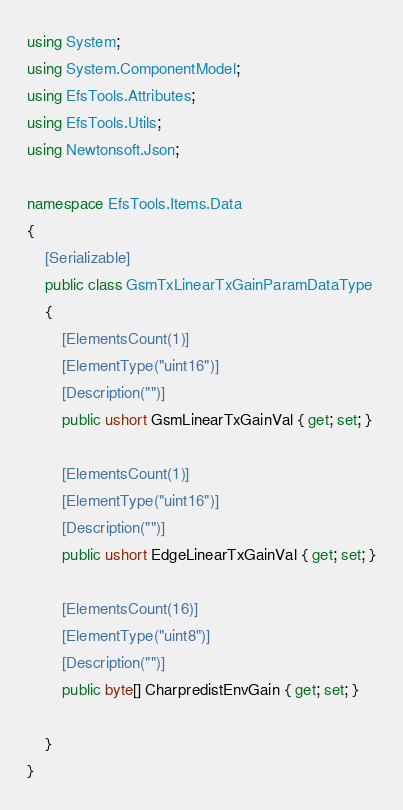Convert code to text. <code><loc_0><loc_0><loc_500><loc_500><_C#_>using System;
using System.ComponentModel;
using EfsTools.Attributes;
using EfsTools.Utils;
using Newtonsoft.Json;

namespace EfsTools.Items.Data
{
    [Serializable]
    public class GsmTxLinearTxGainParamDataType
    {
        [ElementsCount(1)]
        [ElementType("uint16")]
        [Description("")]
        public ushort GsmLinearTxGainVal { get; set; }
        
        [ElementsCount(1)]
        [ElementType("uint16")]
        [Description("")]
        public ushort EdgeLinearTxGainVal { get; set; }
        
        [ElementsCount(16)]
        [ElementType("uint8")]
        [Description("")]
        public byte[] CharpredistEnvGain { get; set; }
        
    }
}
</code> 